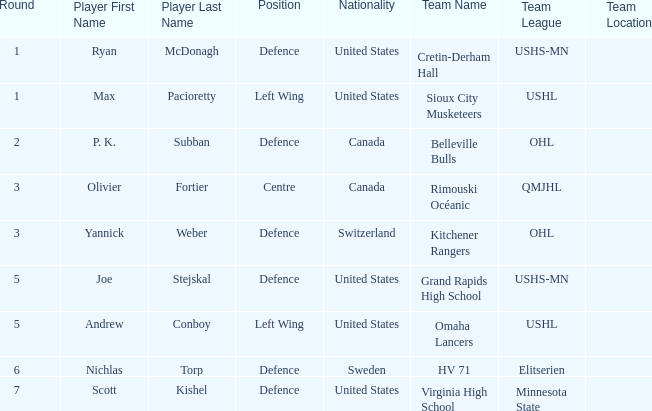Which College/junior/club team (league) was the player from Switzerland from? Kitchener Rangers ( OHL ). 